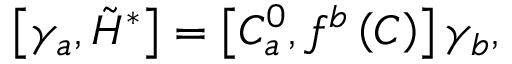<formula> <loc_0><loc_0><loc_500><loc_500>\left [ \gamma _ { a } , \tilde { H } ^ { * } \right ] = \left [ C _ { a } ^ { 0 } , f ^ { b } \left ( C \right ) \right ] \gamma _ { b } ,</formula> 